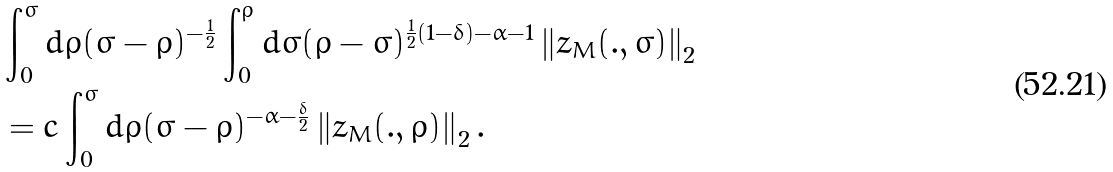<formula> <loc_0><loc_0><loc_500><loc_500>& \int _ { 0 } ^ { \sigma } d \rho ( \sigma - \rho ) ^ { - \frac { 1 } { 2 } } \int _ { 0 } ^ { \rho } d \varsigma ( \rho - \varsigma ) ^ { \frac { 1 } { 2 } ( 1 - \delta ) - \alpha - 1 } \left \| z _ { M } ( . , \varsigma ) \right \| _ { 2 } \\ & = c \int _ { 0 } ^ { \sigma } d \rho ( \sigma - \rho ) ^ { - \alpha - \frac { \delta } { 2 } } \left \| z _ { M } ( . , \rho ) \right \| _ { 2 } .</formula> 